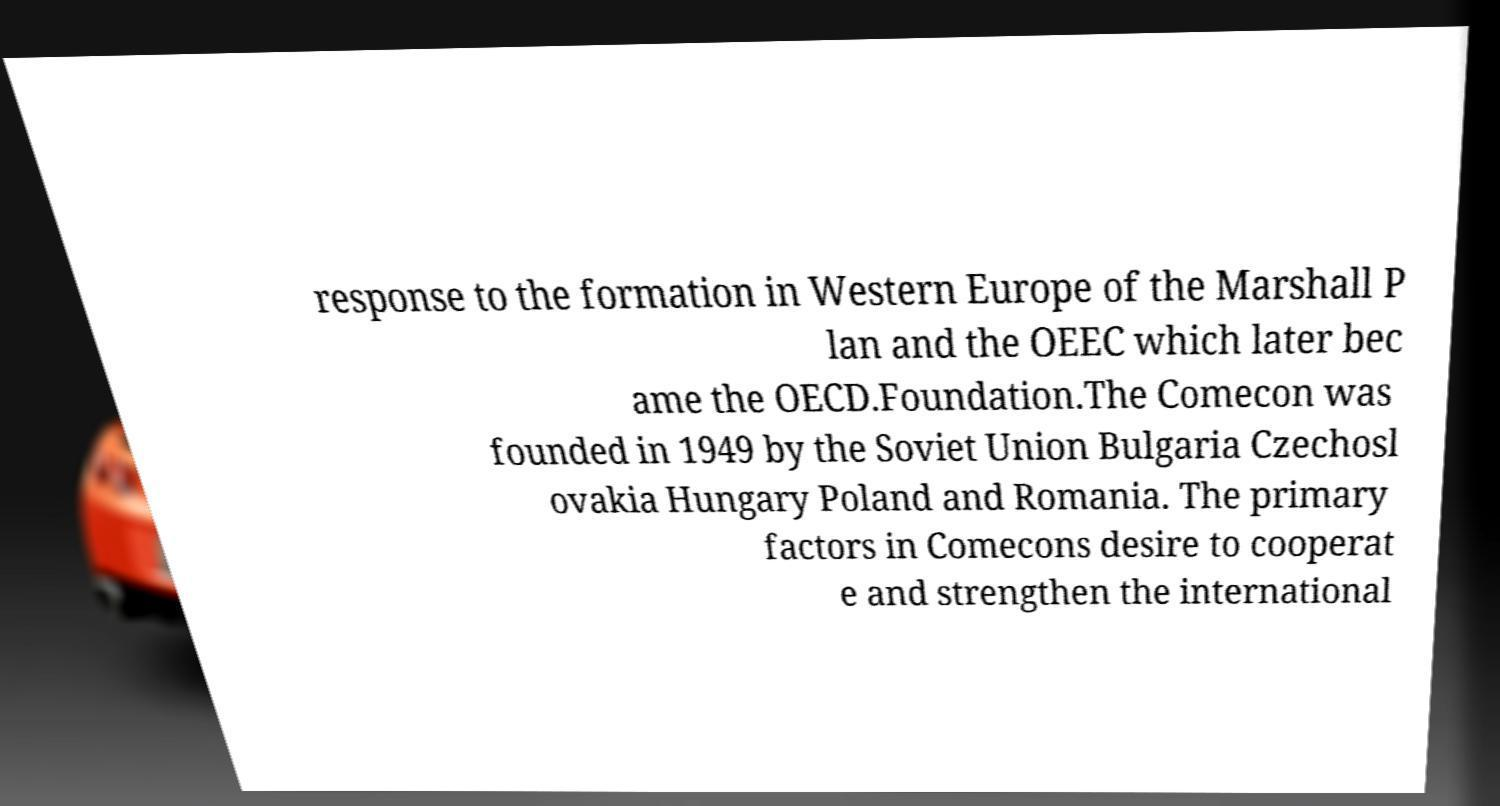Please identify and transcribe the text found in this image. response to the formation in Western Europe of the Marshall P lan and the OEEC which later bec ame the OECD.Foundation.The Comecon was founded in 1949 by the Soviet Union Bulgaria Czechosl ovakia Hungary Poland and Romania. The primary factors in Comecons desire to cooperat e and strengthen the international 